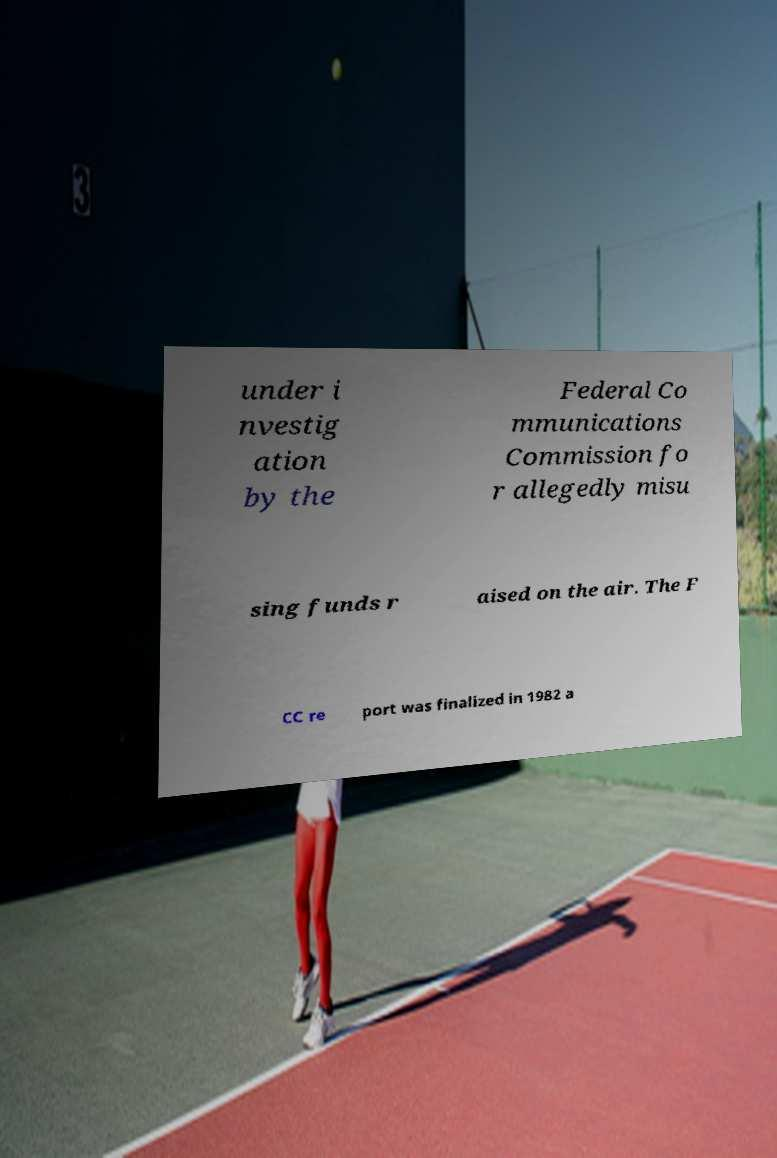I need the written content from this picture converted into text. Can you do that? under i nvestig ation by the Federal Co mmunications Commission fo r allegedly misu sing funds r aised on the air. The F CC re port was finalized in 1982 a 